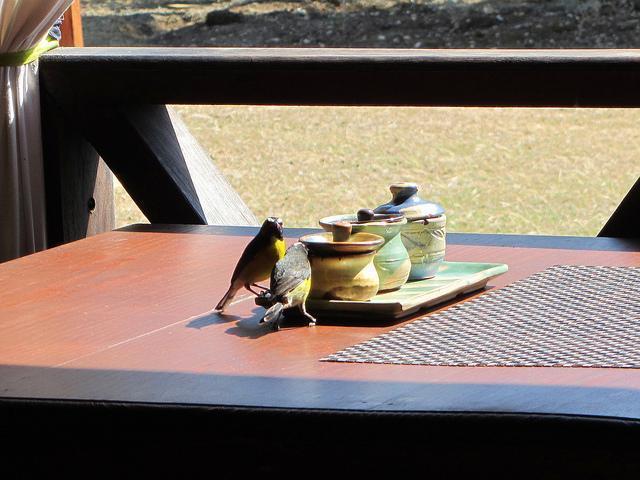Where is this table located at?
From the following four choices, select the correct answer to address the question.
Options: Dinning room, backyard, restaurant, patio. Patio. 